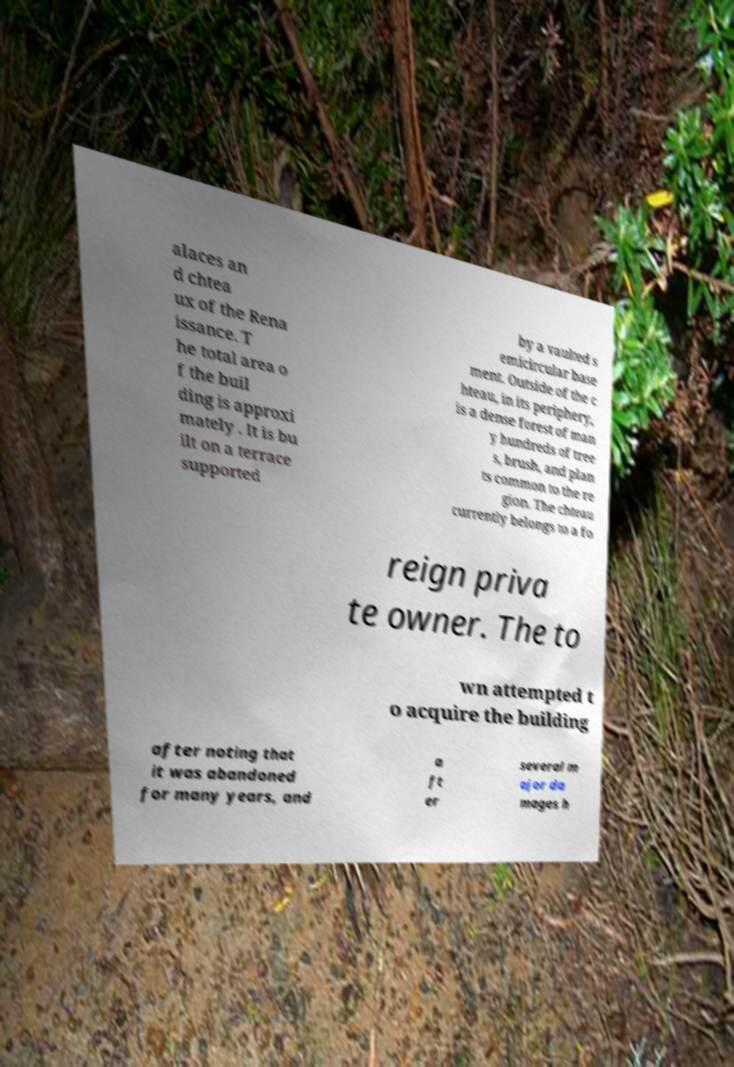I need the written content from this picture converted into text. Can you do that? alaces an d chtea ux of the Rena issance. T he total area o f the buil ding is approxi mately . It is bu ilt on a terrace supported by a vaulted s emicircular base ment. Outside of the c hteau, in its periphery, is a dense forest of man y hundreds of tree s, brush, and plan ts common to the re gion. The chteau currently belongs to a fo reign priva te owner. The to wn attempted t o acquire the building after noting that it was abandoned for many years, and a ft er several m ajor da mages h 